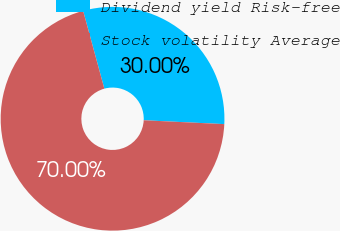<chart> <loc_0><loc_0><loc_500><loc_500><pie_chart><fcel>Dividend yield Risk-free<fcel>Stock volatility Average<nl><fcel>30.0%<fcel>70.0%<nl></chart> 